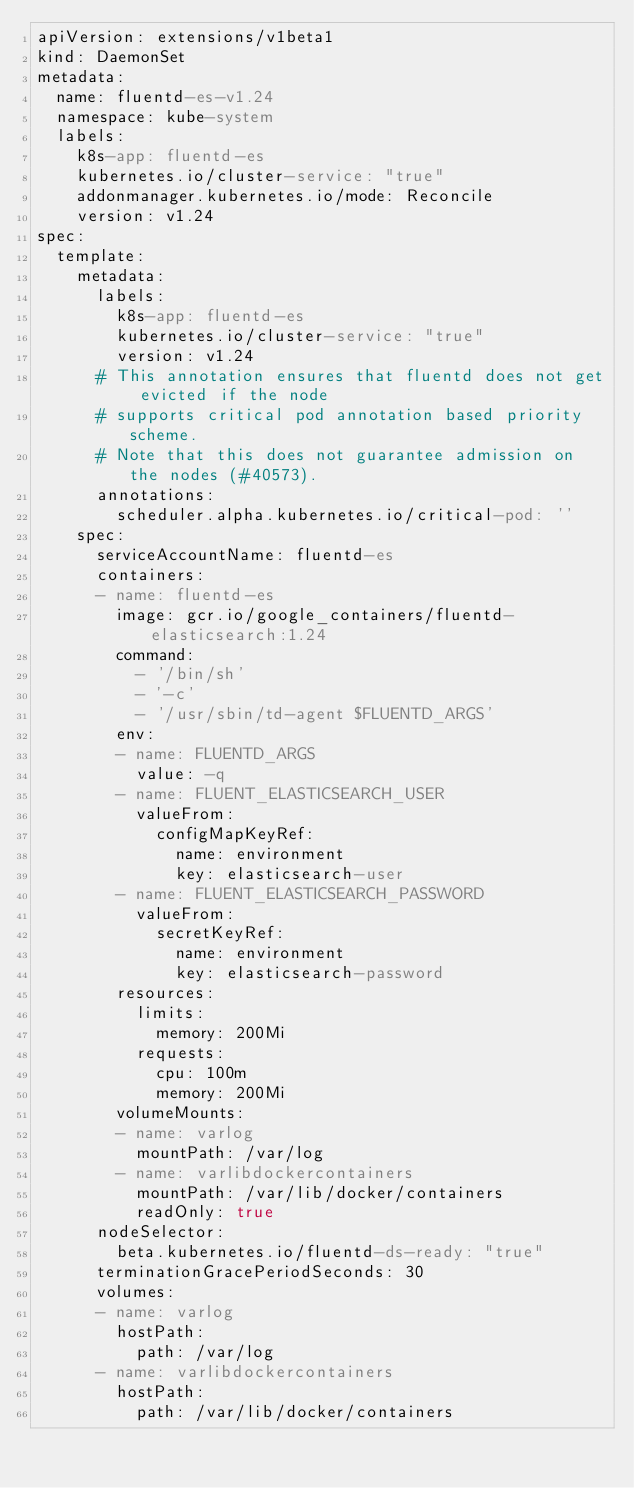Convert code to text. <code><loc_0><loc_0><loc_500><loc_500><_YAML_>apiVersion: extensions/v1beta1
kind: DaemonSet
metadata:
  name: fluentd-es-v1.24
  namespace: kube-system
  labels:
    k8s-app: fluentd-es
    kubernetes.io/cluster-service: "true"
    addonmanager.kubernetes.io/mode: Reconcile
    version: v1.24
spec:
  template:
    metadata:
      labels:
        k8s-app: fluentd-es
        kubernetes.io/cluster-service: "true"
        version: v1.24
      # This annotation ensures that fluentd does not get evicted if the node
      # supports critical pod annotation based priority scheme.
      # Note that this does not guarantee admission on the nodes (#40573).
      annotations:
        scheduler.alpha.kubernetes.io/critical-pod: ''
    spec:
      serviceAccountName: fluentd-es
      containers:
      - name: fluentd-es
        image: gcr.io/google_containers/fluentd-elasticsearch:1.24
        command:
          - '/bin/sh'
          - '-c'
          - '/usr/sbin/td-agent $FLUENTD_ARGS'
        env:
        - name: FLUENTD_ARGS
          value: -q
        - name: FLUENT_ELASTICSEARCH_USER
          valueFrom:
            configMapKeyRef:
              name: environment
              key: elasticsearch-user
        - name: FLUENT_ELASTICSEARCH_PASSWORD
          valueFrom:
            secretKeyRef:
              name: environment
              key: elasticsearch-password
        resources:
          limits:
            memory: 200Mi
          requests:
            cpu: 100m
            memory: 200Mi
        volumeMounts:
        - name: varlog
          mountPath: /var/log
        - name: varlibdockercontainers
          mountPath: /var/lib/docker/containers
          readOnly: true
      nodeSelector:
        beta.kubernetes.io/fluentd-ds-ready: "true"
      terminationGracePeriodSeconds: 30
      volumes:
      - name: varlog
        hostPath:
          path: /var/log
      - name: varlibdockercontainers
        hostPath:
          path: /var/lib/docker/containers
</code> 